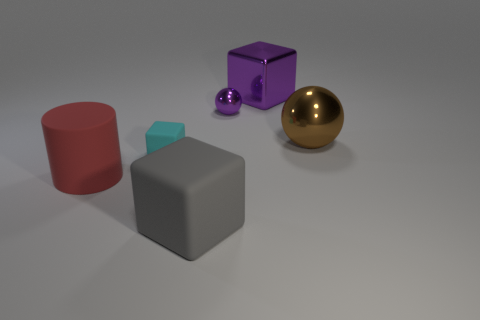Is there any other thing that is the same shape as the red rubber object?
Make the answer very short. No. Is the shape of the cyan rubber object that is to the left of the big purple object the same as the object behind the tiny purple metallic thing?
Offer a terse response. Yes. There is a purple thing that is the same shape as the big gray object; what is it made of?
Your answer should be compact. Metal. How many cylinders are tiny objects or shiny objects?
Your answer should be compact. 0. How many big cubes are made of the same material as the tiny purple sphere?
Give a very brief answer. 1. Do the big cube that is in front of the large cylinder and the small thing in front of the big ball have the same material?
Keep it short and to the point. Yes. There is a rubber cube in front of the large object that is to the left of the large matte block; what number of large matte things are behind it?
Keep it short and to the point. 1. Is the color of the large block that is behind the big red rubber cylinder the same as the tiny object behind the cyan rubber block?
Offer a very short reply. Yes. Is there any other thing that has the same color as the large sphere?
Ensure brevity in your answer.  No. What is the color of the tiny object that is on the right side of the matte block in front of the red matte object?
Offer a very short reply. Purple. 